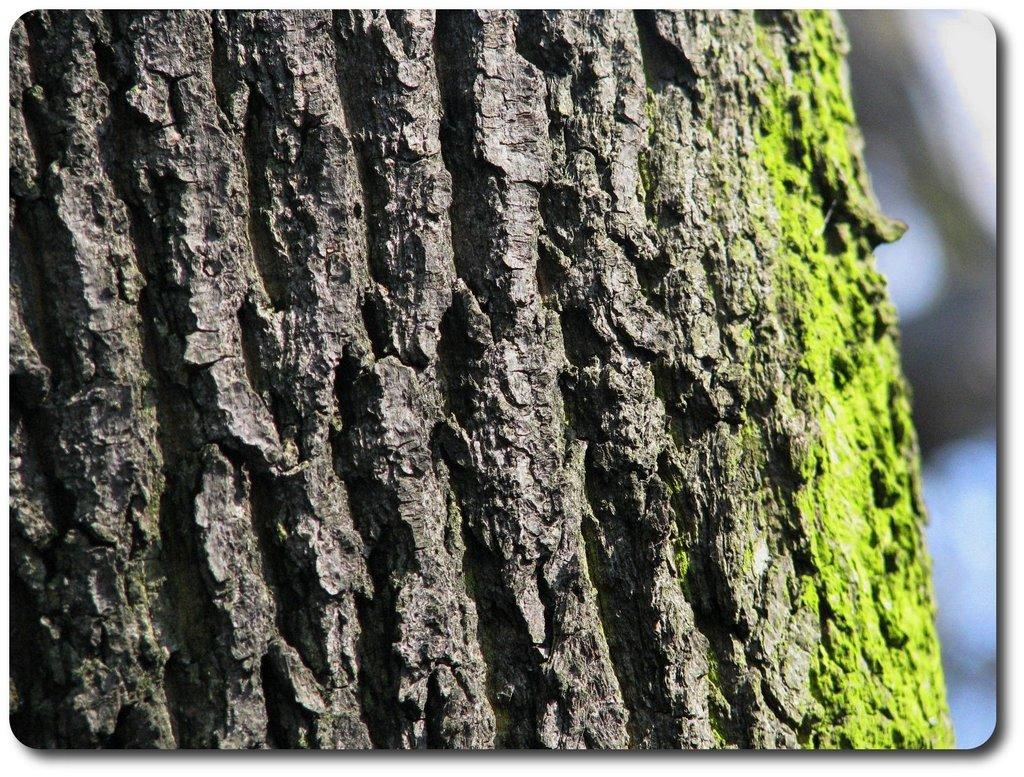What type of tree is visible in the image? There is a wood tree in the image. What color are the objects in the image? There are green color objects in the image. How many houses can be seen in the image? There are no houses present in the image. What type of fruit is hanging from the branches of the wood tree in the image? There is no fruit visible on the wood tree in the image. 